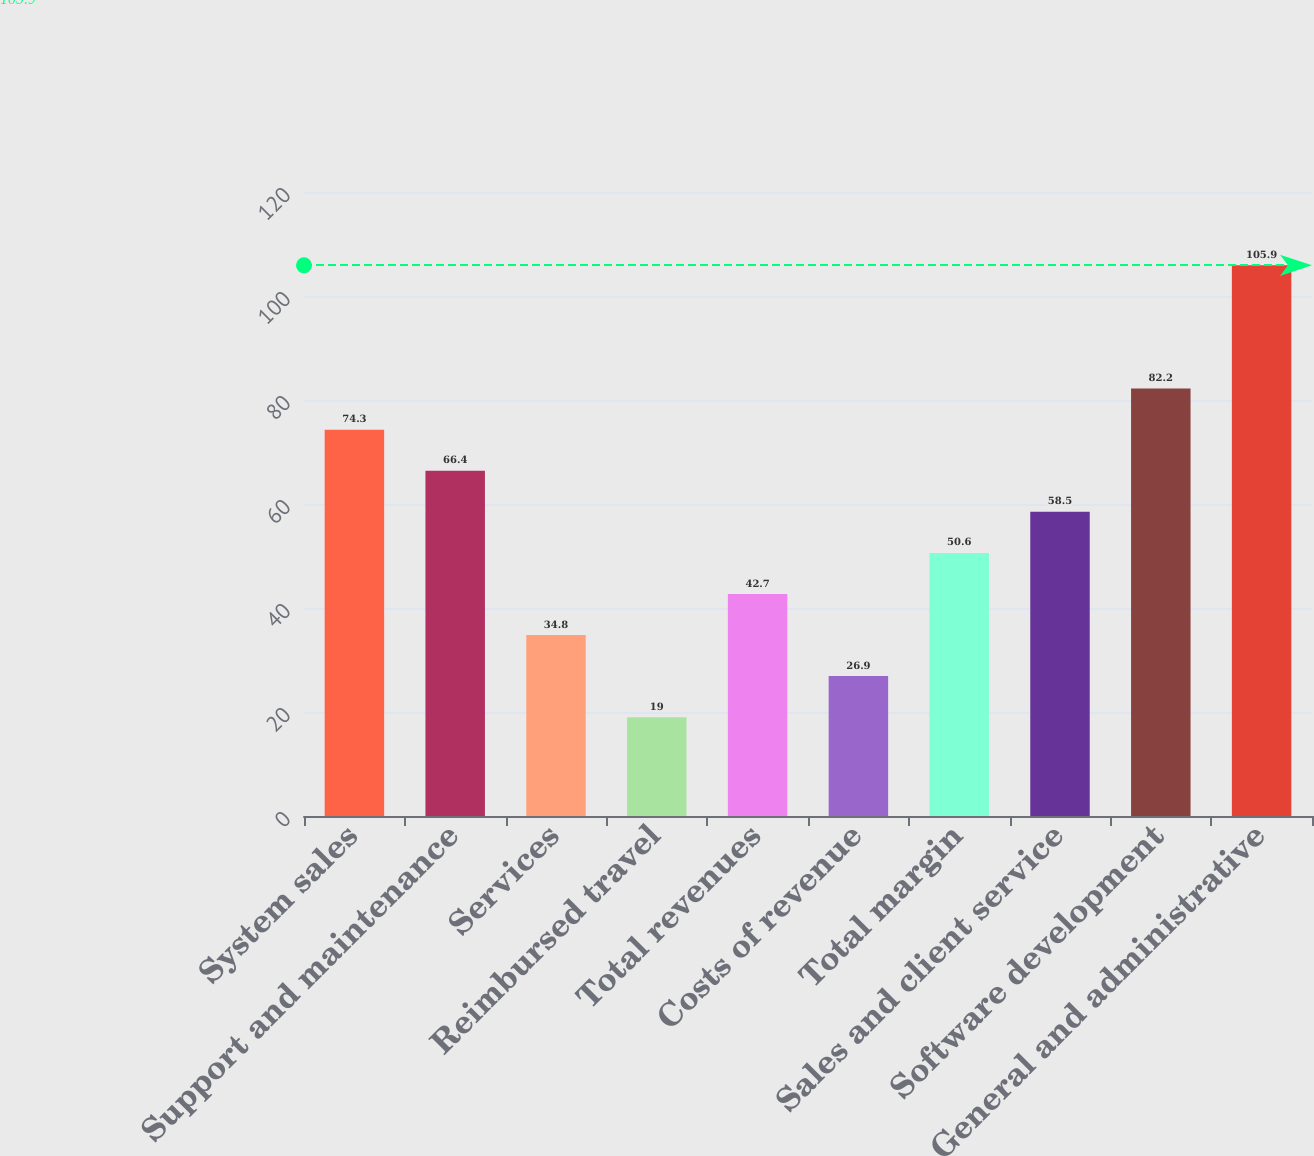Convert chart to OTSL. <chart><loc_0><loc_0><loc_500><loc_500><bar_chart><fcel>System sales<fcel>Support and maintenance<fcel>Services<fcel>Reimbursed travel<fcel>Total revenues<fcel>Costs of revenue<fcel>Total margin<fcel>Sales and client service<fcel>Software development<fcel>General and administrative<nl><fcel>74.3<fcel>66.4<fcel>34.8<fcel>19<fcel>42.7<fcel>26.9<fcel>50.6<fcel>58.5<fcel>82.2<fcel>105.9<nl></chart> 